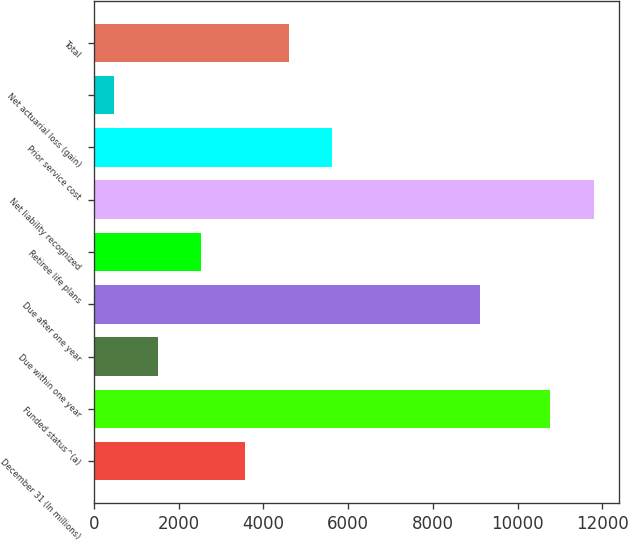Convert chart. <chart><loc_0><loc_0><loc_500><loc_500><bar_chart><fcel>December 31 (In millions)<fcel>Funded status^(a)<fcel>Due within one year<fcel>Due after one year<fcel>Retiree life plans<fcel>Net liability recognized<fcel>Prior service cost<fcel>Net actuarial loss (gain)<fcel>Total<nl><fcel>3564.7<fcel>10774<fcel>1504.9<fcel>9105<fcel>2534.8<fcel>11803.9<fcel>5624.5<fcel>475<fcel>4594.6<nl></chart> 